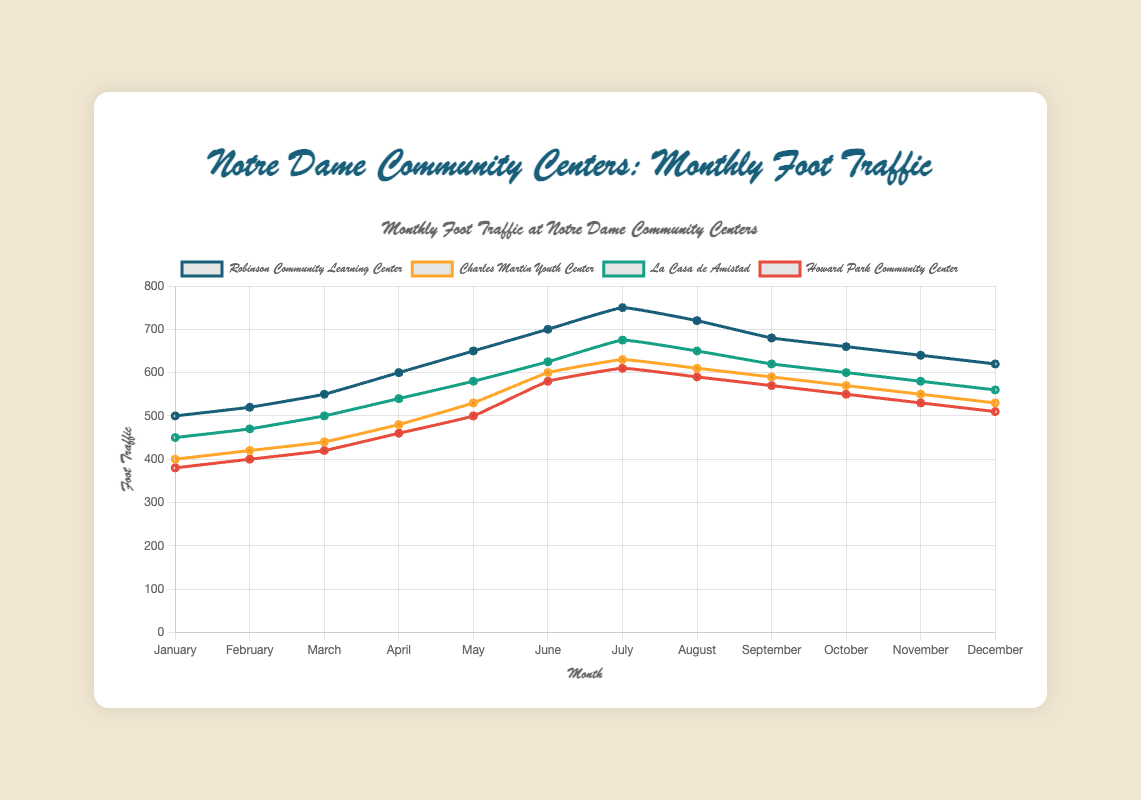Which community center had the highest foot traffic in July? To find the answer, look at the plotted lines for each community center in July. Identify the line that reaches the highest point in that month.
Answer: Robinson Community Learning Center Which two months saw the highest increase in foot traffic for the Robinson Community Learning Center? Identify the months where the Robinson Community Learning Center saw a significant change by comparing the plotted values month-by-month. Calculate the difference and find the highest increase. The difference between June and July is the highest.
Answer: June to July What is the total foot traffic for La Casa de Amistad from January to June? Add the values of foot traffic for each month from January to June for La Casa de Amistad: 450 + 470 + 500 + 540 + 580 + 625 = 3165
Answer: 3165 Which community center had the lowest foot traffic in February? Look at the plotted lines for each community center in February and identify the line with the lowest value.
Answer: Howard Park Community Center During which month did the Charles Martin Youth Center have its peak foot traffic? Find the highest point on the line representing the Charles Martin Youth Center and check the corresponding month.
Answer: July How does the foot traffic for the Robinson Community Learning Center in December compare to that in January? Compare the values for December and January: December has a value of 620, and January has a value of 500. December is higher.
Answer: December is higher By how much did the foot traffic change from May to June for the Howard Park Community Center? Subtract the foot traffic in May from the foot traffic in June: 580 (June) - 500 (May) = 80
Answer: 80 Which community center had the most consistent foot traffic throughout the year? Analyze the variability of the lines. The community center with the flattest line, showing the least variation from month to month, is the most consistent.
Answer: Howard Park Community Center What is the average foot traffic in August across all community centers? Add the foot traffic values for each community center in August and divide by 4: (720 + 610 + 650 + 590) / 4 = 642.5
Answer: 642.5 